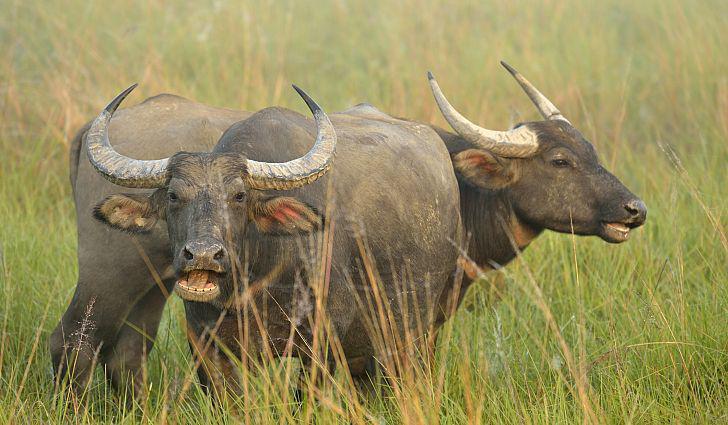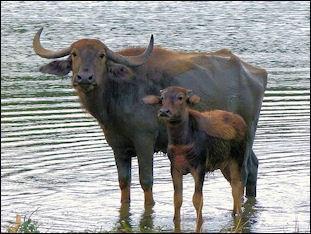The first image is the image on the left, the second image is the image on the right. Examine the images to the left and right. Is the description "Two water buffalos are standing in water." accurate? Answer yes or no. Yes. The first image is the image on the left, the second image is the image on the right. For the images displayed, is the sentence "An image contains a water buffalo standing in water." factually correct? Answer yes or no. Yes. 